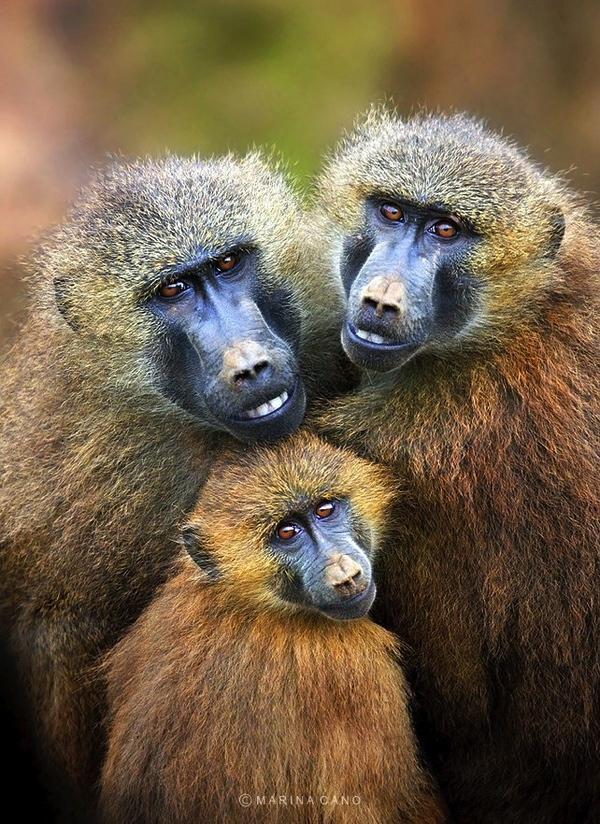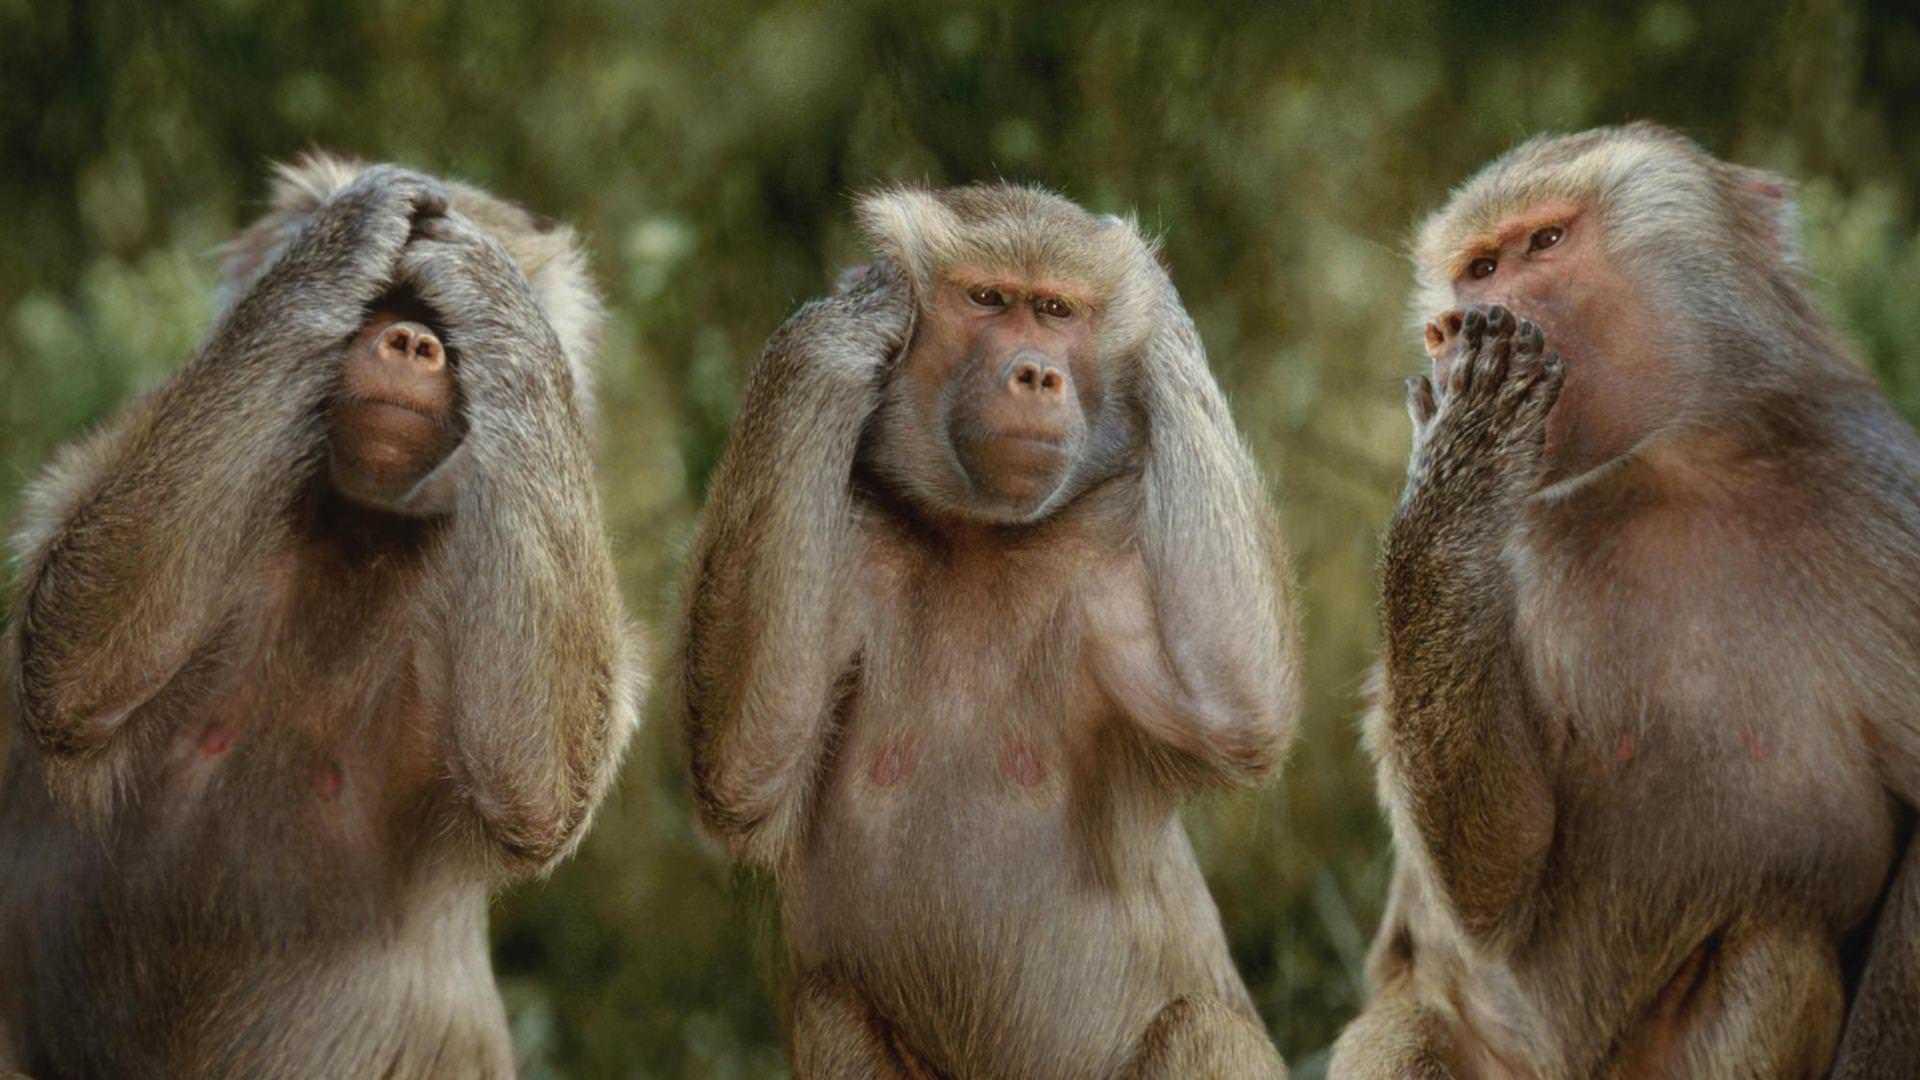The first image is the image on the left, the second image is the image on the right. Given the left and right images, does the statement "There are more monkeys in the image on the right." hold true? Answer yes or no. No. The first image is the image on the left, the second image is the image on the right. Considering the images on both sides, is "The left image shows exactly one adult baboon and one baby baboon." valid? Answer yes or no. No. 